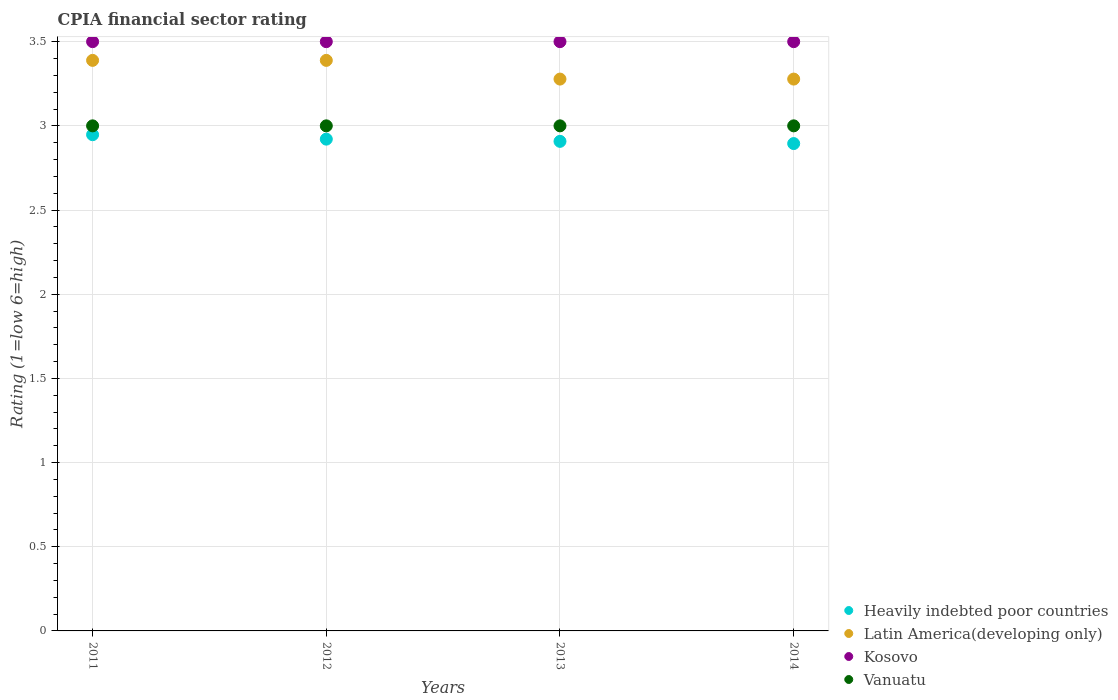Is the number of dotlines equal to the number of legend labels?
Your answer should be compact. Yes. What is the CPIA rating in Latin America(developing only) in 2014?
Your answer should be very brief. 3.28. Across all years, what is the maximum CPIA rating in Heavily indebted poor countries?
Offer a terse response. 2.95. Across all years, what is the minimum CPIA rating in Heavily indebted poor countries?
Give a very brief answer. 2.89. What is the total CPIA rating in Vanuatu in the graph?
Give a very brief answer. 12. What is the difference between the CPIA rating in Heavily indebted poor countries in 2011 and the CPIA rating in Latin America(developing only) in 2013?
Make the answer very short. -0.33. What is the average CPIA rating in Vanuatu per year?
Your answer should be compact. 3. In the year 2011, what is the difference between the CPIA rating in Heavily indebted poor countries and CPIA rating in Latin America(developing only)?
Offer a very short reply. -0.44. In how many years, is the CPIA rating in Heavily indebted poor countries greater than 1.7?
Provide a short and direct response. 4. What is the ratio of the CPIA rating in Heavily indebted poor countries in 2013 to that in 2014?
Offer a terse response. 1. Is the difference between the CPIA rating in Heavily indebted poor countries in 2012 and 2014 greater than the difference between the CPIA rating in Latin America(developing only) in 2012 and 2014?
Ensure brevity in your answer.  No. What is the difference between the highest and the lowest CPIA rating in Vanuatu?
Offer a terse response. 0. Is the sum of the CPIA rating in Heavily indebted poor countries in 2011 and 2013 greater than the maximum CPIA rating in Latin America(developing only) across all years?
Make the answer very short. Yes. Is it the case that in every year, the sum of the CPIA rating in Latin America(developing only) and CPIA rating in Vanuatu  is greater than the sum of CPIA rating in Heavily indebted poor countries and CPIA rating in Kosovo?
Your response must be concise. No. Is it the case that in every year, the sum of the CPIA rating in Vanuatu and CPIA rating in Kosovo  is greater than the CPIA rating in Heavily indebted poor countries?
Provide a short and direct response. Yes. Does the CPIA rating in Heavily indebted poor countries monotonically increase over the years?
Offer a terse response. No. Is the CPIA rating in Vanuatu strictly greater than the CPIA rating in Kosovo over the years?
Offer a very short reply. No. Is the CPIA rating in Kosovo strictly less than the CPIA rating in Latin America(developing only) over the years?
Make the answer very short. No. How many dotlines are there?
Your answer should be compact. 4. Does the graph contain grids?
Ensure brevity in your answer.  Yes. What is the title of the graph?
Keep it short and to the point. CPIA financial sector rating. What is the Rating (1=low 6=high) in Heavily indebted poor countries in 2011?
Offer a terse response. 2.95. What is the Rating (1=low 6=high) of Latin America(developing only) in 2011?
Your response must be concise. 3.39. What is the Rating (1=low 6=high) in Kosovo in 2011?
Make the answer very short. 3.5. What is the Rating (1=low 6=high) of Vanuatu in 2011?
Offer a very short reply. 3. What is the Rating (1=low 6=high) in Heavily indebted poor countries in 2012?
Offer a very short reply. 2.92. What is the Rating (1=low 6=high) in Latin America(developing only) in 2012?
Provide a short and direct response. 3.39. What is the Rating (1=low 6=high) of Kosovo in 2012?
Ensure brevity in your answer.  3.5. What is the Rating (1=low 6=high) in Vanuatu in 2012?
Keep it short and to the point. 3. What is the Rating (1=low 6=high) in Heavily indebted poor countries in 2013?
Offer a very short reply. 2.91. What is the Rating (1=low 6=high) of Latin America(developing only) in 2013?
Keep it short and to the point. 3.28. What is the Rating (1=low 6=high) of Vanuatu in 2013?
Ensure brevity in your answer.  3. What is the Rating (1=low 6=high) in Heavily indebted poor countries in 2014?
Keep it short and to the point. 2.89. What is the Rating (1=low 6=high) in Latin America(developing only) in 2014?
Your answer should be compact. 3.28. Across all years, what is the maximum Rating (1=low 6=high) in Heavily indebted poor countries?
Provide a short and direct response. 2.95. Across all years, what is the maximum Rating (1=low 6=high) of Latin America(developing only)?
Ensure brevity in your answer.  3.39. Across all years, what is the maximum Rating (1=low 6=high) in Kosovo?
Ensure brevity in your answer.  3.5. Across all years, what is the minimum Rating (1=low 6=high) in Heavily indebted poor countries?
Your response must be concise. 2.89. Across all years, what is the minimum Rating (1=low 6=high) of Latin America(developing only)?
Your response must be concise. 3.28. Across all years, what is the minimum Rating (1=low 6=high) in Kosovo?
Provide a succinct answer. 3.5. Across all years, what is the minimum Rating (1=low 6=high) of Vanuatu?
Your answer should be very brief. 3. What is the total Rating (1=low 6=high) in Heavily indebted poor countries in the graph?
Give a very brief answer. 11.67. What is the total Rating (1=low 6=high) of Latin America(developing only) in the graph?
Ensure brevity in your answer.  13.33. What is the total Rating (1=low 6=high) in Kosovo in the graph?
Your answer should be compact. 14. What is the total Rating (1=low 6=high) of Vanuatu in the graph?
Offer a very short reply. 12. What is the difference between the Rating (1=low 6=high) of Heavily indebted poor countries in 2011 and that in 2012?
Provide a succinct answer. 0.03. What is the difference between the Rating (1=low 6=high) in Latin America(developing only) in 2011 and that in 2012?
Your answer should be compact. 0. What is the difference between the Rating (1=low 6=high) of Vanuatu in 2011 and that in 2012?
Make the answer very short. 0. What is the difference between the Rating (1=low 6=high) in Heavily indebted poor countries in 2011 and that in 2013?
Give a very brief answer. 0.04. What is the difference between the Rating (1=low 6=high) of Latin America(developing only) in 2011 and that in 2013?
Offer a terse response. 0.11. What is the difference between the Rating (1=low 6=high) of Kosovo in 2011 and that in 2013?
Offer a very short reply. 0. What is the difference between the Rating (1=low 6=high) of Heavily indebted poor countries in 2011 and that in 2014?
Your response must be concise. 0.05. What is the difference between the Rating (1=low 6=high) of Latin America(developing only) in 2011 and that in 2014?
Make the answer very short. 0.11. What is the difference between the Rating (1=low 6=high) of Heavily indebted poor countries in 2012 and that in 2013?
Provide a succinct answer. 0.01. What is the difference between the Rating (1=low 6=high) of Latin America(developing only) in 2012 and that in 2013?
Make the answer very short. 0.11. What is the difference between the Rating (1=low 6=high) in Kosovo in 2012 and that in 2013?
Offer a terse response. 0. What is the difference between the Rating (1=low 6=high) of Vanuatu in 2012 and that in 2013?
Your response must be concise. 0. What is the difference between the Rating (1=low 6=high) in Heavily indebted poor countries in 2012 and that in 2014?
Your response must be concise. 0.03. What is the difference between the Rating (1=low 6=high) of Kosovo in 2012 and that in 2014?
Make the answer very short. 0. What is the difference between the Rating (1=low 6=high) of Vanuatu in 2012 and that in 2014?
Provide a short and direct response. 0. What is the difference between the Rating (1=low 6=high) of Heavily indebted poor countries in 2013 and that in 2014?
Your answer should be compact. 0.01. What is the difference between the Rating (1=low 6=high) of Vanuatu in 2013 and that in 2014?
Make the answer very short. 0. What is the difference between the Rating (1=low 6=high) of Heavily indebted poor countries in 2011 and the Rating (1=low 6=high) of Latin America(developing only) in 2012?
Offer a terse response. -0.44. What is the difference between the Rating (1=low 6=high) in Heavily indebted poor countries in 2011 and the Rating (1=low 6=high) in Kosovo in 2012?
Your answer should be very brief. -0.55. What is the difference between the Rating (1=low 6=high) of Heavily indebted poor countries in 2011 and the Rating (1=low 6=high) of Vanuatu in 2012?
Your response must be concise. -0.05. What is the difference between the Rating (1=low 6=high) in Latin America(developing only) in 2011 and the Rating (1=low 6=high) in Kosovo in 2012?
Ensure brevity in your answer.  -0.11. What is the difference between the Rating (1=low 6=high) in Latin America(developing only) in 2011 and the Rating (1=low 6=high) in Vanuatu in 2012?
Provide a short and direct response. 0.39. What is the difference between the Rating (1=low 6=high) in Kosovo in 2011 and the Rating (1=low 6=high) in Vanuatu in 2012?
Give a very brief answer. 0.5. What is the difference between the Rating (1=low 6=high) in Heavily indebted poor countries in 2011 and the Rating (1=low 6=high) in Latin America(developing only) in 2013?
Your answer should be very brief. -0.33. What is the difference between the Rating (1=low 6=high) in Heavily indebted poor countries in 2011 and the Rating (1=low 6=high) in Kosovo in 2013?
Provide a short and direct response. -0.55. What is the difference between the Rating (1=low 6=high) of Heavily indebted poor countries in 2011 and the Rating (1=low 6=high) of Vanuatu in 2013?
Offer a very short reply. -0.05. What is the difference between the Rating (1=low 6=high) of Latin America(developing only) in 2011 and the Rating (1=low 6=high) of Kosovo in 2013?
Give a very brief answer. -0.11. What is the difference between the Rating (1=low 6=high) in Latin America(developing only) in 2011 and the Rating (1=low 6=high) in Vanuatu in 2013?
Offer a very short reply. 0.39. What is the difference between the Rating (1=low 6=high) in Heavily indebted poor countries in 2011 and the Rating (1=low 6=high) in Latin America(developing only) in 2014?
Provide a succinct answer. -0.33. What is the difference between the Rating (1=low 6=high) of Heavily indebted poor countries in 2011 and the Rating (1=low 6=high) of Kosovo in 2014?
Make the answer very short. -0.55. What is the difference between the Rating (1=low 6=high) of Heavily indebted poor countries in 2011 and the Rating (1=low 6=high) of Vanuatu in 2014?
Your response must be concise. -0.05. What is the difference between the Rating (1=low 6=high) of Latin America(developing only) in 2011 and the Rating (1=low 6=high) of Kosovo in 2014?
Your answer should be compact. -0.11. What is the difference between the Rating (1=low 6=high) in Latin America(developing only) in 2011 and the Rating (1=low 6=high) in Vanuatu in 2014?
Keep it short and to the point. 0.39. What is the difference between the Rating (1=low 6=high) of Heavily indebted poor countries in 2012 and the Rating (1=low 6=high) of Latin America(developing only) in 2013?
Offer a terse response. -0.36. What is the difference between the Rating (1=low 6=high) in Heavily indebted poor countries in 2012 and the Rating (1=low 6=high) in Kosovo in 2013?
Offer a very short reply. -0.58. What is the difference between the Rating (1=low 6=high) in Heavily indebted poor countries in 2012 and the Rating (1=low 6=high) in Vanuatu in 2013?
Provide a succinct answer. -0.08. What is the difference between the Rating (1=low 6=high) in Latin America(developing only) in 2012 and the Rating (1=low 6=high) in Kosovo in 2013?
Make the answer very short. -0.11. What is the difference between the Rating (1=low 6=high) of Latin America(developing only) in 2012 and the Rating (1=low 6=high) of Vanuatu in 2013?
Keep it short and to the point. 0.39. What is the difference between the Rating (1=low 6=high) of Kosovo in 2012 and the Rating (1=low 6=high) of Vanuatu in 2013?
Keep it short and to the point. 0.5. What is the difference between the Rating (1=low 6=high) of Heavily indebted poor countries in 2012 and the Rating (1=low 6=high) of Latin America(developing only) in 2014?
Keep it short and to the point. -0.36. What is the difference between the Rating (1=low 6=high) in Heavily indebted poor countries in 2012 and the Rating (1=low 6=high) in Kosovo in 2014?
Your answer should be compact. -0.58. What is the difference between the Rating (1=low 6=high) of Heavily indebted poor countries in 2012 and the Rating (1=low 6=high) of Vanuatu in 2014?
Give a very brief answer. -0.08. What is the difference between the Rating (1=low 6=high) in Latin America(developing only) in 2012 and the Rating (1=low 6=high) in Kosovo in 2014?
Make the answer very short. -0.11. What is the difference between the Rating (1=low 6=high) of Latin America(developing only) in 2012 and the Rating (1=low 6=high) of Vanuatu in 2014?
Your answer should be very brief. 0.39. What is the difference between the Rating (1=low 6=high) in Heavily indebted poor countries in 2013 and the Rating (1=low 6=high) in Latin America(developing only) in 2014?
Make the answer very short. -0.37. What is the difference between the Rating (1=low 6=high) of Heavily indebted poor countries in 2013 and the Rating (1=low 6=high) of Kosovo in 2014?
Your answer should be compact. -0.59. What is the difference between the Rating (1=low 6=high) in Heavily indebted poor countries in 2013 and the Rating (1=low 6=high) in Vanuatu in 2014?
Offer a very short reply. -0.09. What is the difference between the Rating (1=low 6=high) in Latin America(developing only) in 2013 and the Rating (1=low 6=high) in Kosovo in 2014?
Offer a terse response. -0.22. What is the difference between the Rating (1=low 6=high) in Latin America(developing only) in 2013 and the Rating (1=low 6=high) in Vanuatu in 2014?
Your answer should be very brief. 0.28. What is the difference between the Rating (1=low 6=high) in Kosovo in 2013 and the Rating (1=low 6=high) in Vanuatu in 2014?
Make the answer very short. 0.5. What is the average Rating (1=low 6=high) of Heavily indebted poor countries per year?
Provide a succinct answer. 2.92. In the year 2011, what is the difference between the Rating (1=low 6=high) of Heavily indebted poor countries and Rating (1=low 6=high) of Latin America(developing only)?
Your answer should be very brief. -0.44. In the year 2011, what is the difference between the Rating (1=low 6=high) in Heavily indebted poor countries and Rating (1=low 6=high) in Kosovo?
Offer a very short reply. -0.55. In the year 2011, what is the difference between the Rating (1=low 6=high) of Heavily indebted poor countries and Rating (1=low 6=high) of Vanuatu?
Make the answer very short. -0.05. In the year 2011, what is the difference between the Rating (1=low 6=high) in Latin America(developing only) and Rating (1=low 6=high) in Kosovo?
Provide a succinct answer. -0.11. In the year 2011, what is the difference between the Rating (1=low 6=high) of Latin America(developing only) and Rating (1=low 6=high) of Vanuatu?
Give a very brief answer. 0.39. In the year 2012, what is the difference between the Rating (1=low 6=high) of Heavily indebted poor countries and Rating (1=low 6=high) of Latin America(developing only)?
Offer a very short reply. -0.47. In the year 2012, what is the difference between the Rating (1=low 6=high) of Heavily indebted poor countries and Rating (1=low 6=high) of Kosovo?
Ensure brevity in your answer.  -0.58. In the year 2012, what is the difference between the Rating (1=low 6=high) in Heavily indebted poor countries and Rating (1=low 6=high) in Vanuatu?
Make the answer very short. -0.08. In the year 2012, what is the difference between the Rating (1=low 6=high) of Latin America(developing only) and Rating (1=low 6=high) of Kosovo?
Your answer should be compact. -0.11. In the year 2012, what is the difference between the Rating (1=low 6=high) of Latin America(developing only) and Rating (1=low 6=high) of Vanuatu?
Keep it short and to the point. 0.39. In the year 2013, what is the difference between the Rating (1=low 6=high) in Heavily indebted poor countries and Rating (1=low 6=high) in Latin America(developing only)?
Offer a terse response. -0.37. In the year 2013, what is the difference between the Rating (1=low 6=high) in Heavily indebted poor countries and Rating (1=low 6=high) in Kosovo?
Provide a succinct answer. -0.59. In the year 2013, what is the difference between the Rating (1=low 6=high) of Heavily indebted poor countries and Rating (1=low 6=high) of Vanuatu?
Your answer should be very brief. -0.09. In the year 2013, what is the difference between the Rating (1=low 6=high) in Latin America(developing only) and Rating (1=low 6=high) in Kosovo?
Ensure brevity in your answer.  -0.22. In the year 2013, what is the difference between the Rating (1=low 6=high) of Latin America(developing only) and Rating (1=low 6=high) of Vanuatu?
Your answer should be compact. 0.28. In the year 2014, what is the difference between the Rating (1=low 6=high) of Heavily indebted poor countries and Rating (1=low 6=high) of Latin America(developing only)?
Offer a very short reply. -0.38. In the year 2014, what is the difference between the Rating (1=low 6=high) in Heavily indebted poor countries and Rating (1=low 6=high) in Kosovo?
Provide a succinct answer. -0.61. In the year 2014, what is the difference between the Rating (1=low 6=high) of Heavily indebted poor countries and Rating (1=low 6=high) of Vanuatu?
Ensure brevity in your answer.  -0.11. In the year 2014, what is the difference between the Rating (1=low 6=high) of Latin America(developing only) and Rating (1=low 6=high) of Kosovo?
Make the answer very short. -0.22. In the year 2014, what is the difference between the Rating (1=low 6=high) of Latin America(developing only) and Rating (1=low 6=high) of Vanuatu?
Ensure brevity in your answer.  0.28. In the year 2014, what is the difference between the Rating (1=low 6=high) in Kosovo and Rating (1=low 6=high) in Vanuatu?
Offer a very short reply. 0.5. What is the ratio of the Rating (1=low 6=high) of Heavily indebted poor countries in 2011 to that in 2012?
Offer a terse response. 1.01. What is the ratio of the Rating (1=low 6=high) of Kosovo in 2011 to that in 2012?
Offer a terse response. 1. What is the ratio of the Rating (1=low 6=high) of Vanuatu in 2011 to that in 2012?
Your response must be concise. 1. What is the ratio of the Rating (1=low 6=high) of Heavily indebted poor countries in 2011 to that in 2013?
Your answer should be very brief. 1.01. What is the ratio of the Rating (1=low 6=high) of Latin America(developing only) in 2011 to that in 2013?
Keep it short and to the point. 1.03. What is the ratio of the Rating (1=low 6=high) of Kosovo in 2011 to that in 2013?
Offer a very short reply. 1. What is the ratio of the Rating (1=low 6=high) of Heavily indebted poor countries in 2011 to that in 2014?
Your answer should be compact. 1.02. What is the ratio of the Rating (1=low 6=high) of Latin America(developing only) in 2011 to that in 2014?
Offer a terse response. 1.03. What is the ratio of the Rating (1=low 6=high) in Vanuatu in 2011 to that in 2014?
Give a very brief answer. 1. What is the ratio of the Rating (1=low 6=high) in Heavily indebted poor countries in 2012 to that in 2013?
Your answer should be very brief. 1. What is the ratio of the Rating (1=low 6=high) in Latin America(developing only) in 2012 to that in 2013?
Give a very brief answer. 1.03. What is the ratio of the Rating (1=low 6=high) in Heavily indebted poor countries in 2012 to that in 2014?
Give a very brief answer. 1.01. What is the ratio of the Rating (1=low 6=high) of Latin America(developing only) in 2012 to that in 2014?
Keep it short and to the point. 1.03. What is the ratio of the Rating (1=low 6=high) in Vanuatu in 2012 to that in 2014?
Give a very brief answer. 1. What is the ratio of the Rating (1=low 6=high) in Kosovo in 2013 to that in 2014?
Offer a terse response. 1. What is the ratio of the Rating (1=low 6=high) of Vanuatu in 2013 to that in 2014?
Give a very brief answer. 1. What is the difference between the highest and the second highest Rating (1=low 6=high) of Heavily indebted poor countries?
Provide a short and direct response. 0.03. What is the difference between the highest and the lowest Rating (1=low 6=high) in Heavily indebted poor countries?
Ensure brevity in your answer.  0.05. What is the difference between the highest and the lowest Rating (1=low 6=high) of Kosovo?
Your response must be concise. 0. What is the difference between the highest and the lowest Rating (1=low 6=high) in Vanuatu?
Ensure brevity in your answer.  0. 